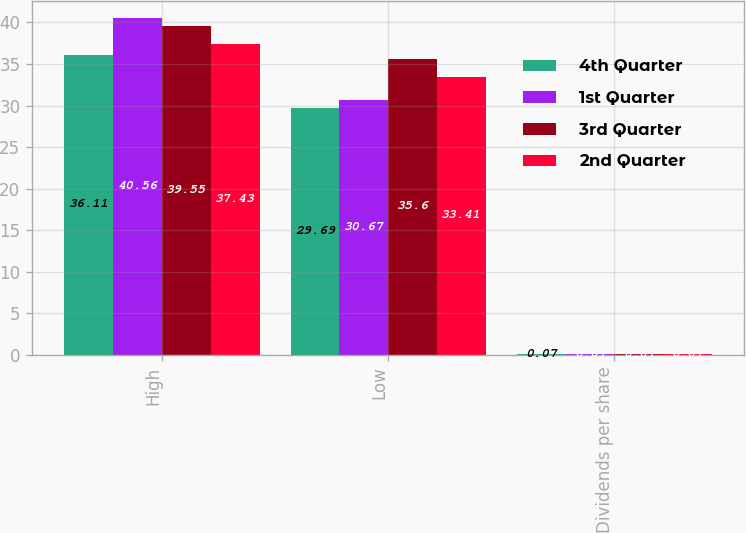<chart> <loc_0><loc_0><loc_500><loc_500><stacked_bar_chart><ecel><fcel>High<fcel>Low<fcel>Dividends per share<nl><fcel>4th Quarter<fcel>36.11<fcel>29.69<fcel>0.07<nl><fcel>1st Quarter<fcel>40.56<fcel>30.67<fcel>0.07<nl><fcel>3rd Quarter<fcel>39.55<fcel>35.6<fcel>0.07<nl><fcel>2nd Quarter<fcel>37.43<fcel>33.41<fcel>0.07<nl></chart> 